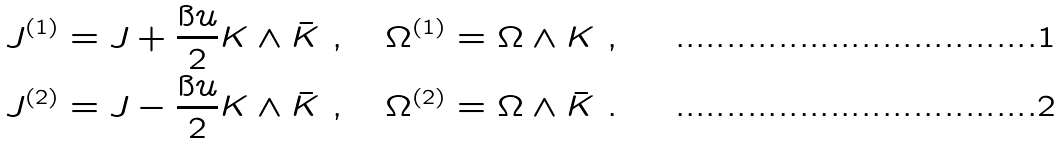Convert formula to latex. <formula><loc_0><loc_0><loc_500><loc_500>J ^ { ( 1 ) } & = J + \frac { \i u } { 2 } K \wedge \bar { K } \ , \quad \Omega ^ { ( 1 ) } = \Omega \wedge K \ , \\ J ^ { ( 2 ) } & = J - \frac { \i u } { 2 } K \wedge \bar { K } \ , \quad \Omega ^ { ( 2 ) } = \Omega \wedge \bar { K } \ .</formula> 